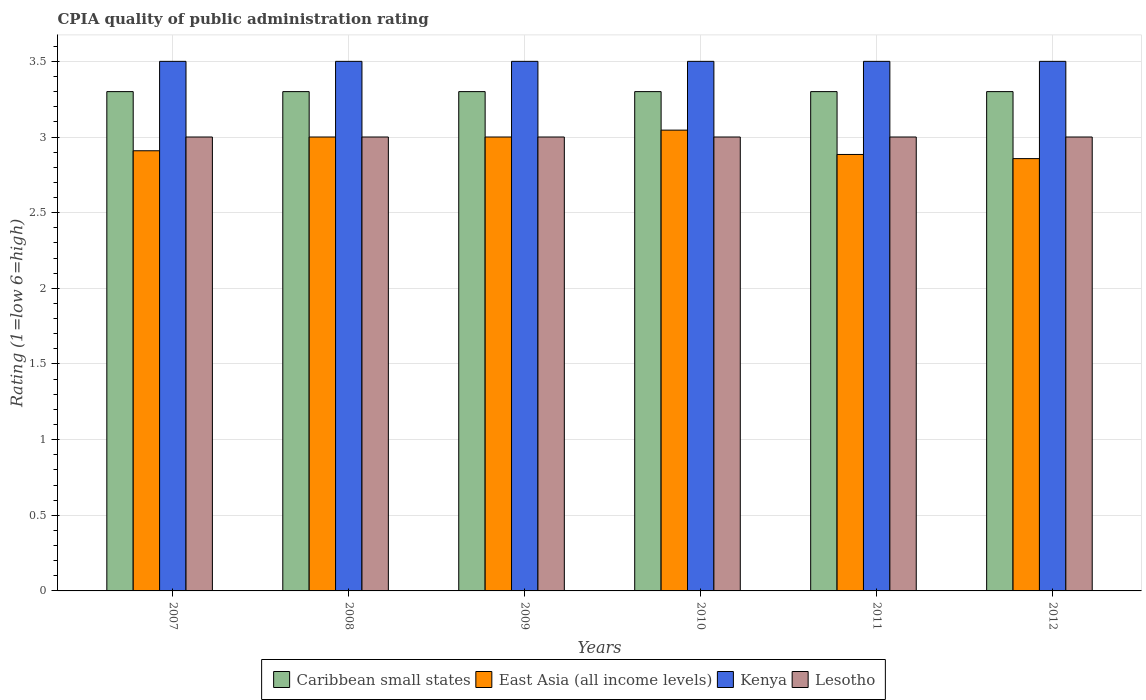Are the number of bars per tick equal to the number of legend labels?
Offer a very short reply. Yes. How many bars are there on the 3rd tick from the left?
Offer a terse response. 4. How many bars are there on the 1st tick from the right?
Ensure brevity in your answer.  4. In how many cases, is the number of bars for a given year not equal to the number of legend labels?
Offer a very short reply. 0. What is the CPIA rating in Caribbean small states in 2012?
Your answer should be very brief. 3.3. Across all years, what is the maximum CPIA rating in Caribbean small states?
Ensure brevity in your answer.  3.3. Across all years, what is the minimum CPIA rating in Caribbean small states?
Ensure brevity in your answer.  3.3. In which year was the CPIA rating in East Asia (all income levels) maximum?
Provide a short and direct response. 2010. In which year was the CPIA rating in Caribbean small states minimum?
Keep it short and to the point. 2007. What is the total CPIA rating in East Asia (all income levels) in the graph?
Offer a very short reply. 17.7. What is the difference between the CPIA rating in East Asia (all income levels) in 2007 and that in 2012?
Your answer should be compact. 0.05. What is the difference between the CPIA rating in East Asia (all income levels) in 2010 and the CPIA rating in Kenya in 2009?
Offer a terse response. -0.45. What is the average CPIA rating in Lesotho per year?
Give a very brief answer. 3. In the year 2010, what is the difference between the CPIA rating in Kenya and CPIA rating in East Asia (all income levels)?
Keep it short and to the point. 0.45. Is the difference between the CPIA rating in Kenya in 2007 and 2012 greater than the difference between the CPIA rating in East Asia (all income levels) in 2007 and 2012?
Offer a terse response. No. What is the difference between the highest and the second highest CPIA rating in Lesotho?
Give a very brief answer. 0. What is the difference between the highest and the lowest CPIA rating in East Asia (all income levels)?
Provide a short and direct response. 0.19. In how many years, is the CPIA rating in Lesotho greater than the average CPIA rating in Lesotho taken over all years?
Make the answer very short. 0. Is the sum of the CPIA rating in Caribbean small states in 2010 and 2011 greater than the maximum CPIA rating in Kenya across all years?
Provide a short and direct response. Yes. What does the 2nd bar from the left in 2011 represents?
Ensure brevity in your answer.  East Asia (all income levels). What does the 1st bar from the right in 2012 represents?
Your answer should be very brief. Lesotho. Is it the case that in every year, the sum of the CPIA rating in East Asia (all income levels) and CPIA rating in Kenya is greater than the CPIA rating in Caribbean small states?
Provide a short and direct response. Yes. Are all the bars in the graph horizontal?
Your answer should be very brief. No. What is the difference between two consecutive major ticks on the Y-axis?
Offer a terse response. 0.5. Are the values on the major ticks of Y-axis written in scientific E-notation?
Make the answer very short. No. Does the graph contain grids?
Offer a terse response. Yes. How many legend labels are there?
Offer a terse response. 4. How are the legend labels stacked?
Your answer should be compact. Horizontal. What is the title of the graph?
Provide a short and direct response. CPIA quality of public administration rating. What is the label or title of the X-axis?
Keep it short and to the point. Years. What is the Rating (1=low 6=high) in East Asia (all income levels) in 2007?
Provide a short and direct response. 2.91. What is the Rating (1=low 6=high) of Lesotho in 2007?
Your answer should be very brief. 3. What is the Rating (1=low 6=high) of Caribbean small states in 2008?
Give a very brief answer. 3.3. What is the Rating (1=low 6=high) of East Asia (all income levels) in 2008?
Keep it short and to the point. 3. What is the Rating (1=low 6=high) in Kenya in 2008?
Your answer should be compact. 3.5. What is the Rating (1=low 6=high) in East Asia (all income levels) in 2009?
Make the answer very short. 3. What is the Rating (1=low 6=high) of Kenya in 2009?
Your answer should be very brief. 3.5. What is the Rating (1=low 6=high) in Caribbean small states in 2010?
Ensure brevity in your answer.  3.3. What is the Rating (1=low 6=high) in East Asia (all income levels) in 2010?
Provide a short and direct response. 3.05. What is the Rating (1=low 6=high) in Lesotho in 2010?
Keep it short and to the point. 3. What is the Rating (1=low 6=high) in Caribbean small states in 2011?
Keep it short and to the point. 3.3. What is the Rating (1=low 6=high) in East Asia (all income levels) in 2011?
Offer a very short reply. 2.88. What is the Rating (1=low 6=high) in Lesotho in 2011?
Make the answer very short. 3. What is the Rating (1=low 6=high) of Caribbean small states in 2012?
Provide a succinct answer. 3.3. What is the Rating (1=low 6=high) in East Asia (all income levels) in 2012?
Make the answer very short. 2.86. What is the Rating (1=low 6=high) in Kenya in 2012?
Give a very brief answer. 3.5. Across all years, what is the maximum Rating (1=low 6=high) in East Asia (all income levels)?
Your answer should be very brief. 3.05. Across all years, what is the maximum Rating (1=low 6=high) of Lesotho?
Provide a succinct answer. 3. Across all years, what is the minimum Rating (1=low 6=high) of East Asia (all income levels)?
Give a very brief answer. 2.86. Across all years, what is the minimum Rating (1=low 6=high) in Kenya?
Offer a terse response. 3.5. Across all years, what is the minimum Rating (1=low 6=high) in Lesotho?
Your answer should be very brief. 3. What is the total Rating (1=low 6=high) in Caribbean small states in the graph?
Provide a short and direct response. 19.8. What is the total Rating (1=low 6=high) of East Asia (all income levels) in the graph?
Your answer should be very brief. 17.7. What is the total Rating (1=low 6=high) in Lesotho in the graph?
Provide a succinct answer. 18. What is the difference between the Rating (1=low 6=high) of Caribbean small states in 2007 and that in 2008?
Ensure brevity in your answer.  0. What is the difference between the Rating (1=low 6=high) in East Asia (all income levels) in 2007 and that in 2008?
Your response must be concise. -0.09. What is the difference between the Rating (1=low 6=high) in Kenya in 2007 and that in 2008?
Offer a terse response. 0. What is the difference between the Rating (1=low 6=high) in Lesotho in 2007 and that in 2008?
Your response must be concise. 0. What is the difference between the Rating (1=low 6=high) of Caribbean small states in 2007 and that in 2009?
Make the answer very short. 0. What is the difference between the Rating (1=low 6=high) in East Asia (all income levels) in 2007 and that in 2009?
Offer a terse response. -0.09. What is the difference between the Rating (1=low 6=high) of Kenya in 2007 and that in 2009?
Give a very brief answer. 0. What is the difference between the Rating (1=low 6=high) in Lesotho in 2007 and that in 2009?
Offer a very short reply. 0. What is the difference between the Rating (1=low 6=high) of East Asia (all income levels) in 2007 and that in 2010?
Provide a short and direct response. -0.14. What is the difference between the Rating (1=low 6=high) in Lesotho in 2007 and that in 2010?
Make the answer very short. 0. What is the difference between the Rating (1=low 6=high) of East Asia (all income levels) in 2007 and that in 2011?
Your response must be concise. 0.02. What is the difference between the Rating (1=low 6=high) of Kenya in 2007 and that in 2011?
Your answer should be very brief. 0. What is the difference between the Rating (1=low 6=high) in Lesotho in 2007 and that in 2011?
Make the answer very short. 0. What is the difference between the Rating (1=low 6=high) in Caribbean small states in 2007 and that in 2012?
Make the answer very short. 0. What is the difference between the Rating (1=low 6=high) of East Asia (all income levels) in 2007 and that in 2012?
Provide a short and direct response. 0.05. What is the difference between the Rating (1=low 6=high) of Lesotho in 2007 and that in 2012?
Make the answer very short. 0. What is the difference between the Rating (1=low 6=high) in Caribbean small states in 2008 and that in 2010?
Keep it short and to the point. 0. What is the difference between the Rating (1=low 6=high) in East Asia (all income levels) in 2008 and that in 2010?
Your response must be concise. -0.05. What is the difference between the Rating (1=low 6=high) in Lesotho in 2008 and that in 2010?
Provide a short and direct response. 0. What is the difference between the Rating (1=low 6=high) of Caribbean small states in 2008 and that in 2011?
Offer a very short reply. 0. What is the difference between the Rating (1=low 6=high) of East Asia (all income levels) in 2008 and that in 2011?
Your response must be concise. 0.12. What is the difference between the Rating (1=low 6=high) of Caribbean small states in 2008 and that in 2012?
Ensure brevity in your answer.  0. What is the difference between the Rating (1=low 6=high) of East Asia (all income levels) in 2008 and that in 2012?
Your answer should be compact. 0.14. What is the difference between the Rating (1=low 6=high) in East Asia (all income levels) in 2009 and that in 2010?
Keep it short and to the point. -0.05. What is the difference between the Rating (1=low 6=high) of East Asia (all income levels) in 2009 and that in 2011?
Give a very brief answer. 0.12. What is the difference between the Rating (1=low 6=high) in Lesotho in 2009 and that in 2011?
Provide a succinct answer. 0. What is the difference between the Rating (1=low 6=high) of East Asia (all income levels) in 2009 and that in 2012?
Offer a very short reply. 0.14. What is the difference between the Rating (1=low 6=high) in Kenya in 2009 and that in 2012?
Your answer should be compact. 0. What is the difference between the Rating (1=low 6=high) of Lesotho in 2009 and that in 2012?
Provide a succinct answer. 0. What is the difference between the Rating (1=low 6=high) of East Asia (all income levels) in 2010 and that in 2011?
Offer a very short reply. 0.16. What is the difference between the Rating (1=low 6=high) in Caribbean small states in 2010 and that in 2012?
Your answer should be compact. 0. What is the difference between the Rating (1=low 6=high) in East Asia (all income levels) in 2010 and that in 2012?
Provide a short and direct response. 0.19. What is the difference between the Rating (1=low 6=high) in Lesotho in 2010 and that in 2012?
Give a very brief answer. 0. What is the difference between the Rating (1=low 6=high) of Caribbean small states in 2011 and that in 2012?
Provide a succinct answer. 0. What is the difference between the Rating (1=low 6=high) of East Asia (all income levels) in 2011 and that in 2012?
Offer a terse response. 0.03. What is the difference between the Rating (1=low 6=high) in Lesotho in 2011 and that in 2012?
Your answer should be compact. 0. What is the difference between the Rating (1=low 6=high) of Caribbean small states in 2007 and the Rating (1=low 6=high) of East Asia (all income levels) in 2008?
Make the answer very short. 0.3. What is the difference between the Rating (1=low 6=high) of Caribbean small states in 2007 and the Rating (1=low 6=high) of Kenya in 2008?
Provide a succinct answer. -0.2. What is the difference between the Rating (1=low 6=high) of Caribbean small states in 2007 and the Rating (1=low 6=high) of Lesotho in 2008?
Ensure brevity in your answer.  0.3. What is the difference between the Rating (1=low 6=high) in East Asia (all income levels) in 2007 and the Rating (1=low 6=high) in Kenya in 2008?
Your answer should be very brief. -0.59. What is the difference between the Rating (1=low 6=high) of East Asia (all income levels) in 2007 and the Rating (1=low 6=high) of Lesotho in 2008?
Offer a terse response. -0.09. What is the difference between the Rating (1=low 6=high) in Kenya in 2007 and the Rating (1=low 6=high) in Lesotho in 2008?
Your answer should be compact. 0.5. What is the difference between the Rating (1=low 6=high) of Caribbean small states in 2007 and the Rating (1=low 6=high) of East Asia (all income levels) in 2009?
Provide a short and direct response. 0.3. What is the difference between the Rating (1=low 6=high) in Caribbean small states in 2007 and the Rating (1=low 6=high) in Kenya in 2009?
Ensure brevity in your answer.  -0.2. What is the difference between the Rating (1=low 6=high) of Caribbean small states in 2007 and the Rating (1=low 6=high) of Lesotho in 2009?
Ensure brevity in your answer.  0.3. What is the difference between the Rating (1=low 6=high) of East Asia (all income levels) in 2007 and the Rating (1=low 6=high) of Kenya in 2009?
Your response must be concise. -0.59. What is the difference between the Rating (1=low 6=high) of East Asia (all income levels) in 2007 and the Rating (1=low 6=high) of Lesotho in 2009?
Your response must be concise. -0.09. What is the difference between the Rating (1=low 6=high) of Caribbean small states in 2007 and the Rating (1=low 6=high) of East Asia (all income levels) in 2010?
Make the answer very short. 0.25. What is the difference between the Rating (1=low 6=high) of Caribbean small states in 2007 and the Rating (1=low 6=high) of Lesotho in 2010?
Give a very brief answer. 0.3. What is the difference between the Rating (1=low 6=high) of East Asia (all income levels) in 2007 and the Rating (1=low 6=high) of Kenya in 2010?
Ensure brevity in your answer.  -0.59. What is the difference between the Rating (1=low 6=high) in East Asia (all income levels) in 2007 and the Rating (1=low 6=high) in Lesotho in 2010?
Offer a terse response. -0.09. What is the difference between the Rating (1=low 6=high) in Kenya in 2007 and the Rating (1=low 6=high) in Lesotho in 2010?
Ensure brevity in your answer.  0.5. What is the difference between the Rating (1=low 6=high) in Caribbean small states in 2007 and the Rating (1=low 6=high) in East Asia (all income levels) in 2011?
Offer a very short reply. 0.42. What is the difference between the Rating (1=low 6=high) in East Asia (all income levels) in 2007 and the Rating (1=low 6=high) in Kenya in 2011?
Your response must be concise. -0.59. What is the difference between the Rating (1=low 6=high) in East Asia (all income levels) in 2007 and the Rating (1=low 6=high) in Lesotho in 2011?
Your response must be concise. -0.09. What is the difference between the Rating (1=low 6=high) of Kenya in 2007 and the Rating (1=low 6=high) of Lesotho in 2011?
Give a very brief answer. 0.5. What is the difference between the Rating (1=low 6=high) of Caribbean small states in 2007 and the Rating (1=low 6=high) of East Asia (all income levels) in 2012?
Provide a succinct answer. 0.44. What is the difference between the Rating (1=low 6=high) of Caribbean small states in 2007 and the Rating (1=low 6=high) of Kenya in 2012?
Your response must be concise. -0.2. What is the difference between the Rating (1=low 6=high) in East Asia (all income levels) in 2007 and the Rating (1=low 6=high) in Kenya in 2012?
Your response must be concise. -0.59. What is the difference between the Rating (1=low 6=high) in East Asia (all income levels) in 2007 and the Rating (1=low 6=high) in Lesotho in 2012?
Offer a very short reply. -0.09. What is the difference between the Rating (1=low 6=high) in Kenya in 2007 and the Rating (1=low 6=high) in Lesotho in 2012?
Offer a very short reply. 0.5. What is the difference between the Rating (1=low 6=high) of Caribbean small states in 2008 and the Rating (1=low 6=high) of Lesotho in 2009?
Your answer should be compact. 0.3. What is the difference between the Rating (1=low 6=high) of East Asia (all income levels) in 2008 and the Rating (1=low 6=high) of Kenya in 2009?
Keep it short and to the point. -0.5. What is the difference between the Rating (1=low 6=high) in East Asia (all income levels) in 2008 and the Rating (1=low 6=high) in Lesotho in 2009?
Offer a terse response. 0. What is the difference between the Rating (1=low 6=high) of Kenya in 2008 and the Rating (1=low 6=high) of Lesotho in 2009?
Offer a very short reply. 0.5. What is the difference between the Rating (1=low 6=high) in Caribbean small states in 2008 and the Rating (1=low 6=high) in East Asia (all income levels) in 2010?
Give a very brief answer. 0.25. What is the difference between the Rating (1=low 6=high) in East Asia (all income levels) in 2008 and the Rating (1=low 6=high) in Lesotho in 2010?
Your answer should be compact. 0. What is the difference between the Rating (1=low 6=high) in Caribbean small states in 2008 and the Rating (1=low 6=high) in East Asia (all income levels) in 2011?
Offer a terse response. 0.42. What is the difference between the Rating (1=low 6=high) in Caribbean small states in 2008 and the Rating (1=low 6=high) in Lesotho in 2011?
Ensure brevity in your answer.  0.3. What is the difference between the Rating (1=low 6=high) of East Asia (all income levels) in 2008 and the Rating (1=low 6=high) of Lesotho in 2011?
Your response must be concise. 0. What is the difference between the Rating (1=low 6=high) in Kenya in 2008 and the Rating (1=low 6=high) in Lesotho in 2011?
Give a very brief answer. 0.5. What is the difference between the Rating (1=low 6=high) of Caribbean small states in 2008 and the Rating (1=low 6=high) of East Asia (all income levels) in 2012?
Provide a succinct answer. 0.44. What is the difference between the Rating (1=low 6=high) in Caribbean small states in 2008 and the Rating (1=low 6=high) in Lesotho in 2012?
Your answer should be compact. 0.3. What is the difference between the Rating (1=low 6=high) in East Asia (all income levels) in 2008 and the Rating (1=low 6=high) in Kenya in 2012?
Ensure brevity in your answer.  -0.5. What is the difference between the Rating (1=low 6=high) of East Asia (all income levels) in 2008 and the Rating (1=low 6=high) of Lesotho in 2012?
Provide a succinct answer. 0. What is the difference between the Rating (1=low 6=high) of Caribbean small states in 2009 and the Rating (1=low 6=high) of East Asia (all income levels) in 2010?
Ensure brevity in your answer.  0.25. What is the difference between the Rating (1=low 6=high) in Caribbean small states in 2009 and the Rating (1=low 6=high) in Kenya in 2010?
Ensure brevity in your answer.  -0.2. What is the difference between the Rating (1=low 6=high) in East Asia (all income levels) in 2009 and the Rating (1=low 6=high) in Kenya in 2010?
Ensure brevity in your answer.  -0.5. What is the difference between the Rating (1=low 6=high) of Kenya in 2009 and the Rating (1=low 6=high) of Lesotho in 2010?
Your response must be concise. 0.5. What is the difference between the Rating (1=low 6=high) of Caribbean small states in 2009 and the Rating (1=low 6=high) of East Asia (all income levels) in 2011?
Make the answer very short. 0.42. What is the difference between the Rating (1=low 6=high) of Caribbean small states in 2009 and the Rating (1=low 6=high) of Kenya in 2011?
Make the answer very short. -0.2. What is the difference between the Rating (1=low 6=high) of East Asia (all income levels) in 2009 and the Rating (1=low 6=high) of Kenya in 2011?
Provide a short and direct response. -0.5. What is the difference between the Rating (1=low 6=high) of East Asia (all income levels) in 2009 and the Rating (1=low 6=high) of Lesotho in 2011?
Your answer should be very brief. 0. What is the difference between the Rating (1=low 6=high) of Kenya in 2009 and the Rating (1=low 6=high) of Lesotho in 2011?
Provide a succinct answer. 0.5. What is the difference between the Rating (1=low 6=high) of Caribbean small states in 2009 and the Rating (1=low 6=high) of East Asia (all income levels) in 2012?
Keep it short and to the point. 0.44. What is the difference between the Rating (1=low 6=high) in Caribbean small states in 2009 and the Rating (1=low 6=high) in Kenya in 2012?
Give a very brief answer. -0.2. What is the difference between the Rating (1=low 6=high) in East Asia (all income levels) in 2009 and the Rating (1=low 6=high) in Lesotho in 2012?
Your answer should be compact. 0. What is the difference between the Rating (1=low 6=high) of Caribbean small states in 2010 and the Rating (1=low 6=high) of East Asia (all income levels) in 2011?
Provide a short and direct response. 0.42. What is the difference between the Rating (1=low 6=high) of Caribbean small states in 2010 and the Rating (1=low 6=high) of Lesotho in 2011?
Your response must be concise. 0.3. What is the difference between the Rating (1=low 6=high) in East Asia (all income levels) in 2010 and the Rating (1=low 6=high) in Kenya in 2011?
Your answer should be compact. -0.45. What is the difference between the Rating (1=low 6=high) in East Asia (all income levels) in 2010 and the Rating (1=low 6=high) in Lesotho in 2011?
Your response must be concise. 0.05. What is the difference between the Rating (1=low 6=high) in Caribbean small states in 2010 and the Rating (1=low 6=high) in East Asia (all income levels) in 2012?
Provide a succinct answer. 0.44. What is the difference between the Rating (1=low 6=high) in Caribbean small states in 2010 and the Rating (1=low 6=high) in Lesotho in 2012?
Provide a short and direct response. 0.3. What is the difference between the Rating (1=low 6=high) of East Asia (all income levels) in 2010 and the Rating (1=low 6=high) of Kenya in 2012?
Make the answer very short. -0.45. What is the difference between the Rating (1=low 6=high) in East Asia (all income levels) in 2010 and the Rating (1=low 6=high) in Lesotho in 2012?
Your answer should be very brief. 0.05. What is the difference between the Rating (1=low 6=high) of Caribbean small states in 2011 and the Rating (1=low 6=high) of East Asia (all income levels) in 2012?
Offer a terse response. 0.44. What is the difference between the Rating (1=low 6=high) in Caribbean small states in 2011 and the Rating (1=low 6=high) in Lesotho in 2012?
Your answer should be very brief. 0.3. What is the difference between the Rating (1=low 6=high) of East Asia (all income levels) in 2011 and the Rating (1=low 6=high) of Kenya in 2012?
Offer a very short reply. -0.62. What is the difference between the Rating (1=low 6=high) of East Asia (all income levels) in 2011 and the Rating (1=low 6=high) of Lesotho in 2012?
Provide a short and direct response. -0.12. What is the average Rating (1=low 6=high) in Caribbean small states per year?
Provide a short and direct response. 3.3. What is the average Rating (1=low 6=high) in East Asia (all income levels) per year?
Your answer should be compact. 2.95. What is the average Rating (1=low 6=high) in Kenya per year?
Your answer should be very brief. 3.5. What is the average Rating (1=low 6=high) in Lesotho per year?
Your answer should be very brief. 3. In the year 2007, what is the difference between the Rating (1=low 6=high) in Caribbean small states and Rating (1=low 6=high) in East Asia (all income levels)?
Ensure brevity in your answer.  0.39. In the year 2007, what is the difference between the Rating (1=low 6=high) of Caribbean small states and Rating (1=low 6=high) of Kenya?
Provide a short and direct response. -0.2. In the year 2007, what is the difference between the Rating (1=low 6=high) in East Asia (all income levels) and Rating (1=low 6=high) in Kenya?
Keep it short and to the point. -0.59. In the year 2007, what is the difference between the Rating (1=low 6=high) in East Asia (all income levels) and Rating (1=low 6=high) in Lesotho?
Provide a succinct answer. -0.09. In the year 2007, what is the difference between the Rating (1=low 6=high) of Kenya and Rating (1=low 6=high) of Lesotho?
Keep it short and to the point. 0.5. In the year 2008, what is the difference between the Rating (1=low 6=high) in Caribbean small states and Rating (1=low 6=high) in Kenya?
Give a very brief answer. -0.2. In the year 2008, what is the difference between the Rating (1=low 6=high) of East Asia (all income levels) and Rating (1=low 6=high) of Kenya?
Provide a short and direct response. -0.5. In the year 2008, what is the difference between the Rating (1=low 6=high) of East Asia (all income levels) and Rating (1=low 6=high) of Lesotho?
Make the answer very short. 0. In the year 2009, what is the difference between the Rating (1=low 6=high) of Caribbean small states and Rating (1=low 6=high) of East Asia (all income levels)?
Ensure brevity in your answer.  0.3. In the year 2009, what is the difference between the Rating (1=low 6=high) in East Asia (all income levels) and Rating (1=low 6=high) in Kenya?
Your answer should be compact. -0.5. In the year 2009, what is the difference between the Rating (1=low 6=high) of Kenya and Rating (1=low 6=high) of Lesotho?
Make the answer very short. 0.5. In the year 2010, what is the difference between the Rating (1=low 6=high) in Caribbean small states and Rating (1=low 6=high) in East Asia (all income levels)?
Offer a very short reply. 0.25. In the year 2010, what is the difference between the Rating (1=low 6=high) in East Asia (all income levels) and Rating (1=low 6=high) in Kenya?
Give a very brief answer. -0.45. In the year 2010, what is the difference between the Rating (1=low 6=high) in East Asia (all income levels) and Rating (1=low 6=high) in Lesotho?
Keep it short and to the point. 0.05. In the year 2011, what is the difference between the Rating (1=low 6=high) in Caribbean small states and Rating (1=low 6=high) in East Asia (all income levels)?
Ensure brevity in your answer.  0.42. In the year 2011, what is the difference between the Rating (1=low 6=high) in Caribbean small states and Rating (1=low 6=high) in Lesotho?
Provide a short and direct response. 0.3. In the year 2011, what is the difference between the Rating (1=low 6=high) in East Asia (all income levels) and Rating (1=low 6=high) in Kenya?
Your answer should be very brief. -0.62. In the year 2011, what is the difference between the Rating (1=low 6=high) in East Asia (all income levels) and Rating (1=low 6=high) in Lesotho?
Offer a very short reply. -0.12. In the year 2012, what is the difference between the Rating (1=low 6=high) of Caribbean small states and Rating (1=low 6=high) of East Asia (all income levels)?
Offer a very short reply. 0.44. In the year 2012, what is the difference between the Rating (1=low 6=high) of Caribbean small states and Rating (1=low 6=high) of Kenya?
Keep it short and to the point. -0.2. In the year 2012, what is the difference between the Rating (1=low 6=high) in East Asia (all income levels) and Rating (1=low 6=high) in Kenya?
Ensure brevity in your answer.  -0.64. In the year 2012, what is the difference between the Rating (1=low 6=high) in East Asia (all income levels) and Rating (1=low 6=high) in Lesotho?
Make the answer very short. -0.14. In the year 2012, what is the difference between the Rating (1=low 6=high) of Kenya and Rating (1=low 6=high) of Lesotho?
Your response must be concise. 0.5. What is the ratio of the Rating (1=low 6=high) of East Asia (all income levels) in 2007 to that in 2008?
Provide a short and direct response. 0.97. What is the ratio of the Rating (1=low 6=high) in Lesotho in 2007 to that in 2008?
Keep it short and to the point. 1. What is the ratio of the Rating (1=low 6=high) in Caribbean small states in 2007 to that in 2009?
Keep it short and to the point. 1. What is the ratio of the Rating (1=low 6=high) of East Asia (all income levels) in 2007 to that in 2009?
Your answer should be compact. 0.97. What is the ratio of the Rating (1=low 6=high) of Kenya in 2007 to that in 2009?
Offer a very short reply. 1. What is the ratio of the Rating (1=low 6=high) in Lesotho in 2007 to that in 2009?
Provide a succinct answer. 1. What is the ratio of the Rating (1=low 6=high) of Caribbean small states in 2007 to that in 2010?
Give a very brief answer. 1. What is the ratio of the Rating (1=low 6=high) in East Asia (all income levels) in 2007 to that in 2010?
Provide a succinct answer. 0.96. What is the ratio of the Rating (1=low 6=high) in Kenya in 2007 to that in 2010?
Give a very brief answer. 1. What is the ratio of the Rating (1=low 6=high) of Caribbean small states in 2007 to that in 2011?
Your answer should be very brief. 1. What is the ratio of the Rating (1=low 6=high) in East Asia (all income levels) in 2007 to that in 2011?
Provide a short and direct response. 1.01. What is the ratio of the Rating (1=low 6=high) in Kenya in 2007 to that in 2011?
Provide a short and direct response. 1. What is the ratio of the Rating (1=low 6=high) in Caribbean small states in 2007 to that in 2012?
Ensure brevity in your answer.  1. What is the ratio of the Rating (1=low 6=high) in East Asia (all income levels) in 2007 to that in 2012?
Your answer should be compact. 1.02. What is the ratio of the Rating (1=low 6=high) of Kenya in 2007 to that in 2012?
Your answer should be compact. 1. What is the ratio of the Rating (1=low 6=high) in Caribbean small states in 2008 to that in 2009?
Offer a terse response. 1. What is the ratio of the Rating (1=low 6=high) of East Asia (all income levels) in 2008 to that in 2009?
Ensure brevity in your answer.  1. What is the ratio of the Rating (1=low 6=high) of East Asia (all income levels) in 2008 to that in 2010?
Your answer should be compact. 0.99. What is the ratio of the Rating (1=low 6=high) of Caribbean small states in 2008 to that in 2011?
Your answer should be very brief. 1. What is the ratio of the Rating (1=low 6=high) of East Asia (all income levels) in 2008 to that in 2011?
Your response must be concise. 1.04. What is the ratio of the Rating (1=low 6=high) of Kenya in 2008 to that in 2011?
Your response must be concise. 1. What is the ratio of the Rating (1=low 6=high) of Lesotho in 2008 to that in 2011?
Offer a terse response. 1. What is the ratio of the Rating (1=low 6=high) of Caribbean small states in 2008 to that in 2012?
Your answer should be very brief. 1. What is the ratio of the Rating (1=low 6=high) in East Asia (all income levels) in 2008 to that in 2012?
Give a very brief answer. 1.05. What is the ratio of the Rating (1=low 6=high) in East Asia (all income levels) in 2009 to that in 2010?
Provide a succinct answer. 0.99. What is the ratio of the Rating (1=low 6=high) of Kenya in 2009 to that in 2010?
Ensure brevity in your answer.  1. What is the ratio of the Rating (1=low 6=high) of Caribbean small states in 2009 to that in 2011?
Provide a short and direct response. 1. What is the ratio of the Rating (1=low 6=high) in Kenya in 2009 to that in 2011?
Keep it short and to the point. 1. What is the ratio of the Rating (1=low 6=high) in Caribbean small states in 2009 to that in 2012?
Your answer should be very brief. 1. What is the ratio of the Rating (1=low 6=high) of Kenya in 2009 to that in 2012?
Your answer should be compact. 1. What is the ratio of the Rating (1=low 6=high) of Caribbean small states in 2010 to that in 2011?
Offer a very short reply. 1. What is the ratio of the Rating (1=low 6=high) of East Asia (all income levels) in 2010 to that in 2011?
Give a very brief answer. 1.06. What is the ratio of the Rating (1=low 6=high) in Kenya in 2010 to that in 2011?
Offer a terse response. 1. What is the ratio of the Rating (1=low 6=high) in Lesotho in 2010 to that in 2011?
Give a very brief answer. 1. What is the ratio of the Rating (1=low 6=high) in Caribbean small states in 2010 to that in 2012?
Offer a very short reply. 1. What is the ratio of the Rating (1=low 6=high) in East Asia (all income levels) in 2010 to that in 2012?
Your answer should be very brief. 1.07. What is the ratio of the Rating (1=low 6=high) in Kenya in 2010 to that in 2012?
Keep it short and to the point. 1. What is the ratio of the Rating (1=low 6=high) in Lesotho in 2010 to that in 2012?
Your answer should be compact. 1. What is the ratio of the Rating (1=low 6=high) in East Asia (all income levels) in 2011 to that in 2012?
Give a very brief answer. 1.01. What is the difference between the highest and the second highest Rating (1=low 6=high) in Caribbean small states?
Ensure brevity in your answer.  0. What is the difference between the highest and the second highest Rating (1=low 6=high) in East Asia (all income levels)?
Offer a very short reply. 0.05. What is the difference between the highest and the second highest Rating (1=low 6=high) in Lesotho?
Make the answer very short. 0. What is the difference between the highest and the lowest Rating (1=low 6=high) in Caribbean small states?
Your response must be concise. 0. What is the difference between the highest and the lowest Rating (1=low 6=high) in East Asia (all income levels)?
Make the answer very short. 0.19. What is the difference between the highest and the lowest Rating (1=low 6=high) of Kenya?
Your answer should be very brief. 0. What is the difference between the highest and the lowest Rating (1=low 6=high) of Lesotho?
Provide a succinct answer. 0. 